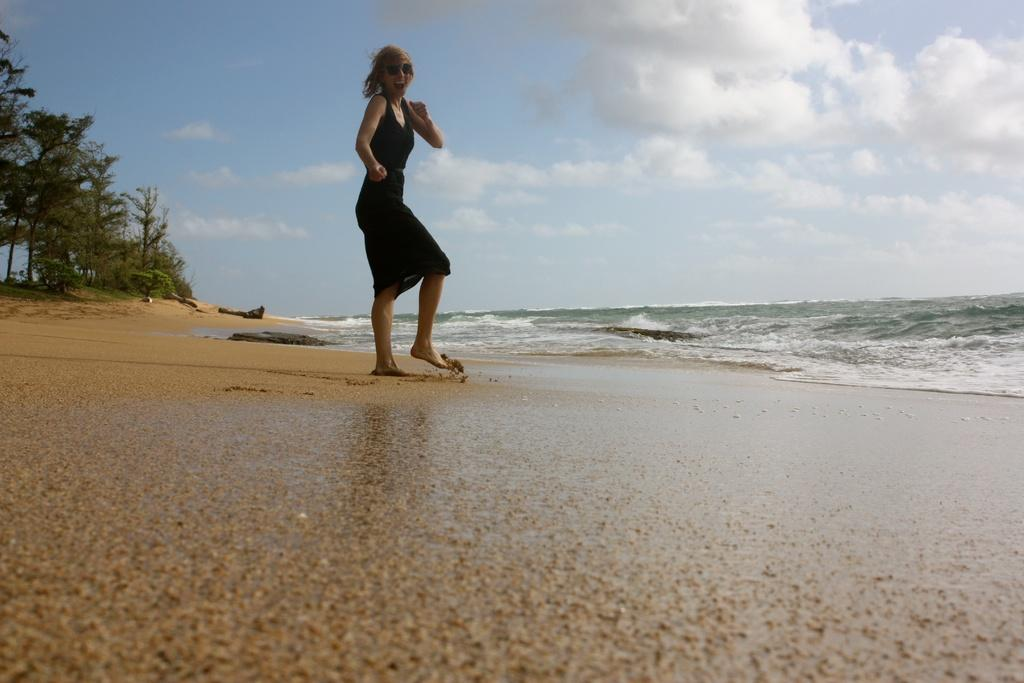What is the main subject of the image? There is a woman standing in the image. What can be seen on the right side of the image? There is water on the right side of the image. What type of vegetation is on the left side of the image? There are green trees on the left side of the image. What is visible at the top of the image? The sky is visible at the top of the image. How would you describe the sky in the image? The sky is cloudy in the image. Can you see a squirrel riding a carriage in the image? No, there is no squirrel or carriage present in the image. Is there a cannon visible in the image? No, there is no cannon present in the image. 